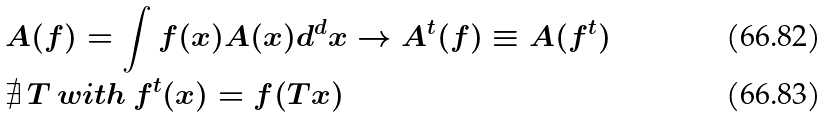Convert formula to latex. <formula><loc_0><loc_0><loc_500><loc_500>& A ( f ) = \int f ( x ) A ( x ) d ^ { d } x \rightarrow A ^ { t } ( f ) \equiv A ( f ^ { t } ) \\ & \nexists \, T \, w i t h \, f ^ { t } ( x ) = f ( T x )</formula> 